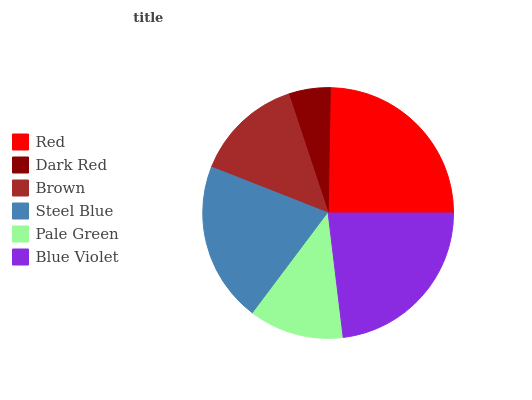Is Dark Red the minimum?
Answer yes or no. Yes. Is Red the maximum?
Answer yes or no. Yes. Is Brown the minimum?
Answer yes or no. No. Is Brown the maximum?
Answer yes or no. No. Is Brown greater than Dark Red?
Answer yes or no. Yes. Is Dark Red less than Brown?
Answer yes or no. Yes. Is Dark Red greater than Brown?
Answer yes or no. No. Is Brown less than Dark Red?
Answer yes or no. No. Is Steel Blue the high median?
Answer yes or no. Yes. Is Brown the low median?
Answer yes or no. Yes. Is Pale Green the high median?
Answer yes or no. No. Is Dark Red the low median?
Answer yes or no. No. 